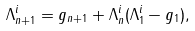<formula> <loc_0><loc_0><loc_500><loc_500>\Lambda ^ { i } _ { n + 1 } = g _ { n + 1 } + \Lambda ^ { i } _ { n } ( \Lambda _ { 1 } ^ { i } - g _ { 1 } ) ,</formula> 